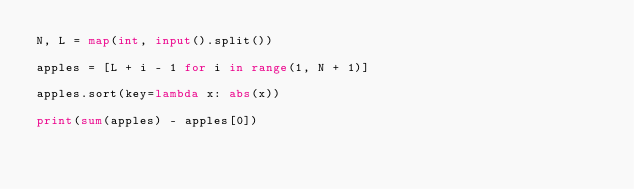<code> <loc_0><loc_0><loc_500><loc_500><_Python_>N, L = map(int, input().split())

apples = [L + i - 1 for i in range(1, N + 1)]

apples.sort(key=lambda x: abs(x))

print(sum(apples) - apples[0])</code> 